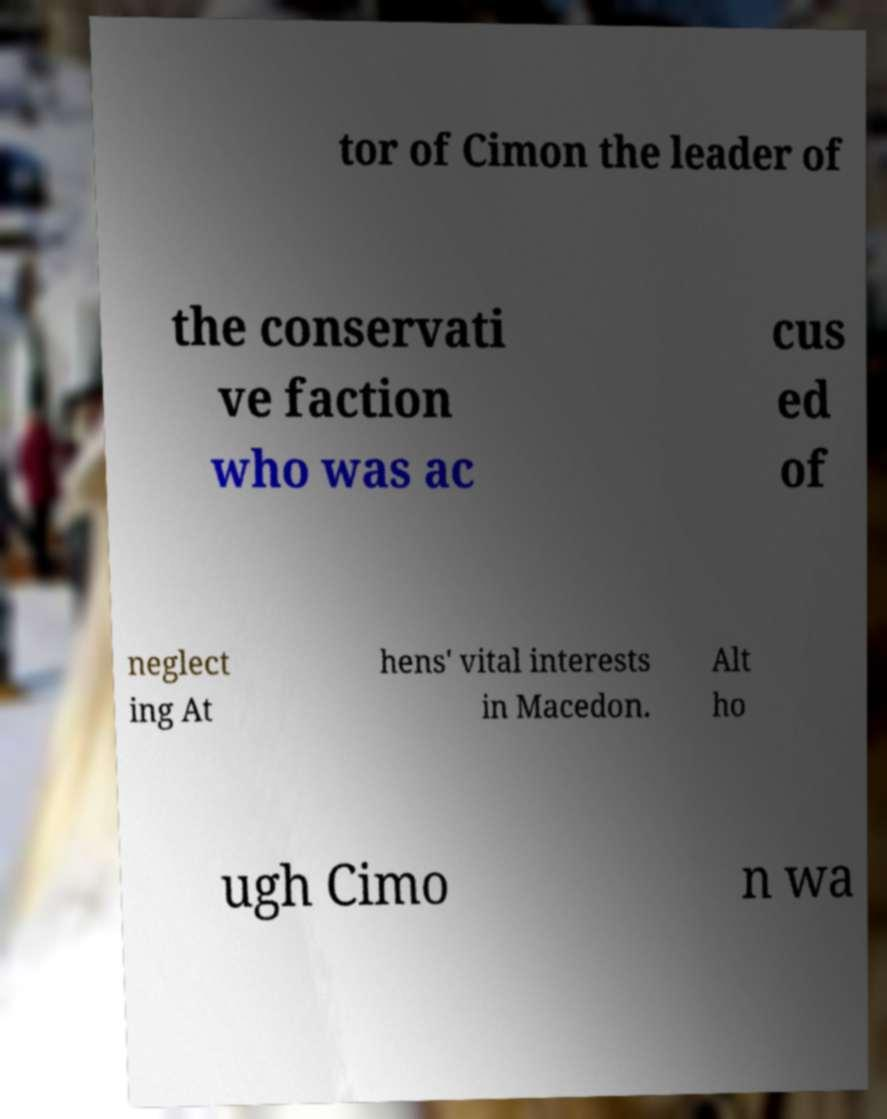Please read and relay the text visible in this image. What does it say? tor of Cimon the leader of the conservati ve faction who was ac cus ed of neglect ing At hens' vital interests in Macedon. Alt ho ugh Cimo n wa 